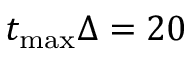Convert formula to latex. <formula><loc_0><loc_0><loc_500><loc_500>t _ { \max } \Delta = 2 0</formula> 